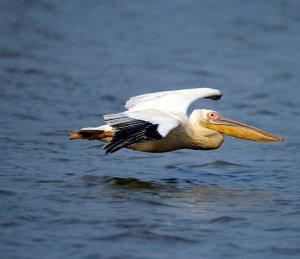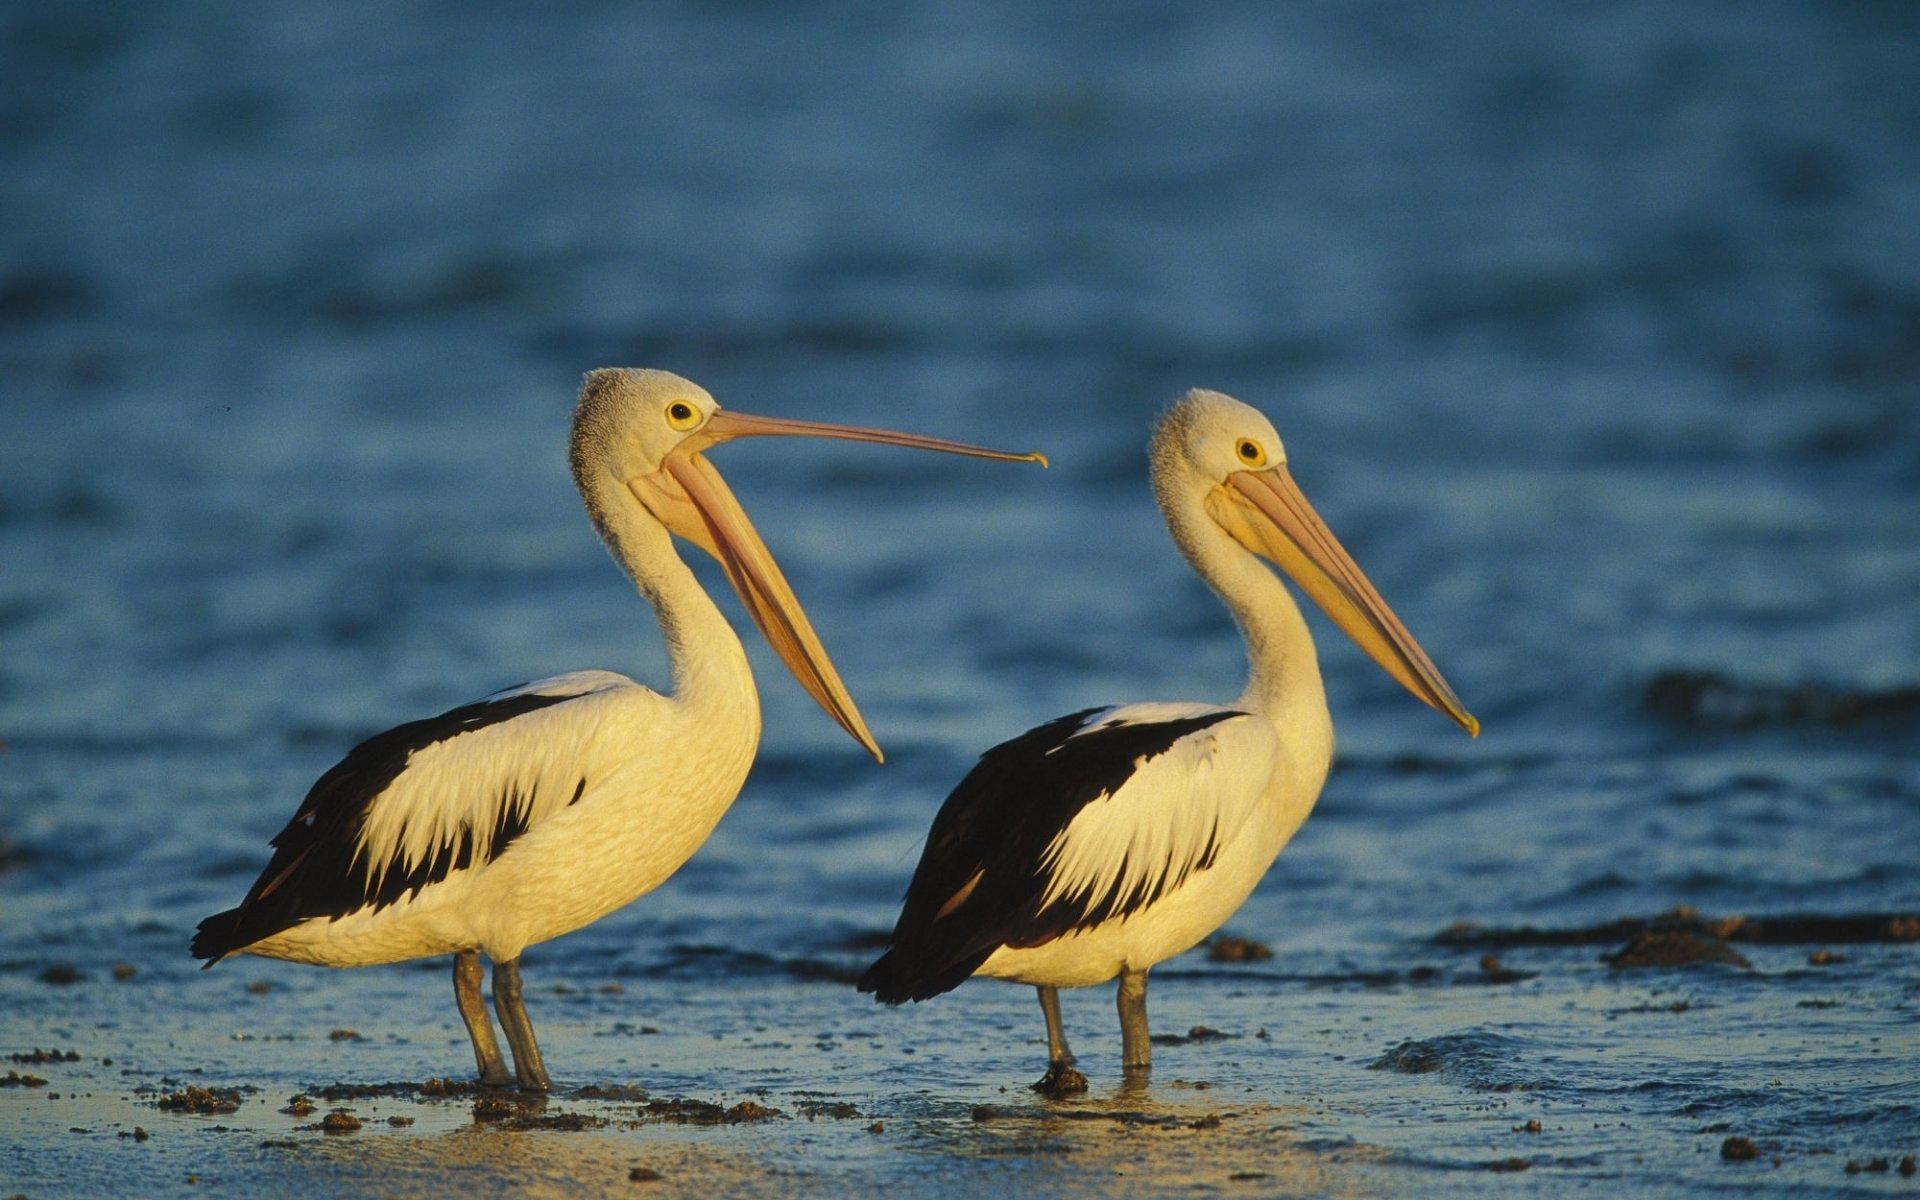The first image is the image on the left, the second image is the image on the right. Given the left and right images, does the statement "Both of the birds are in the air above the water." hold true? Answer yes or no. No. 